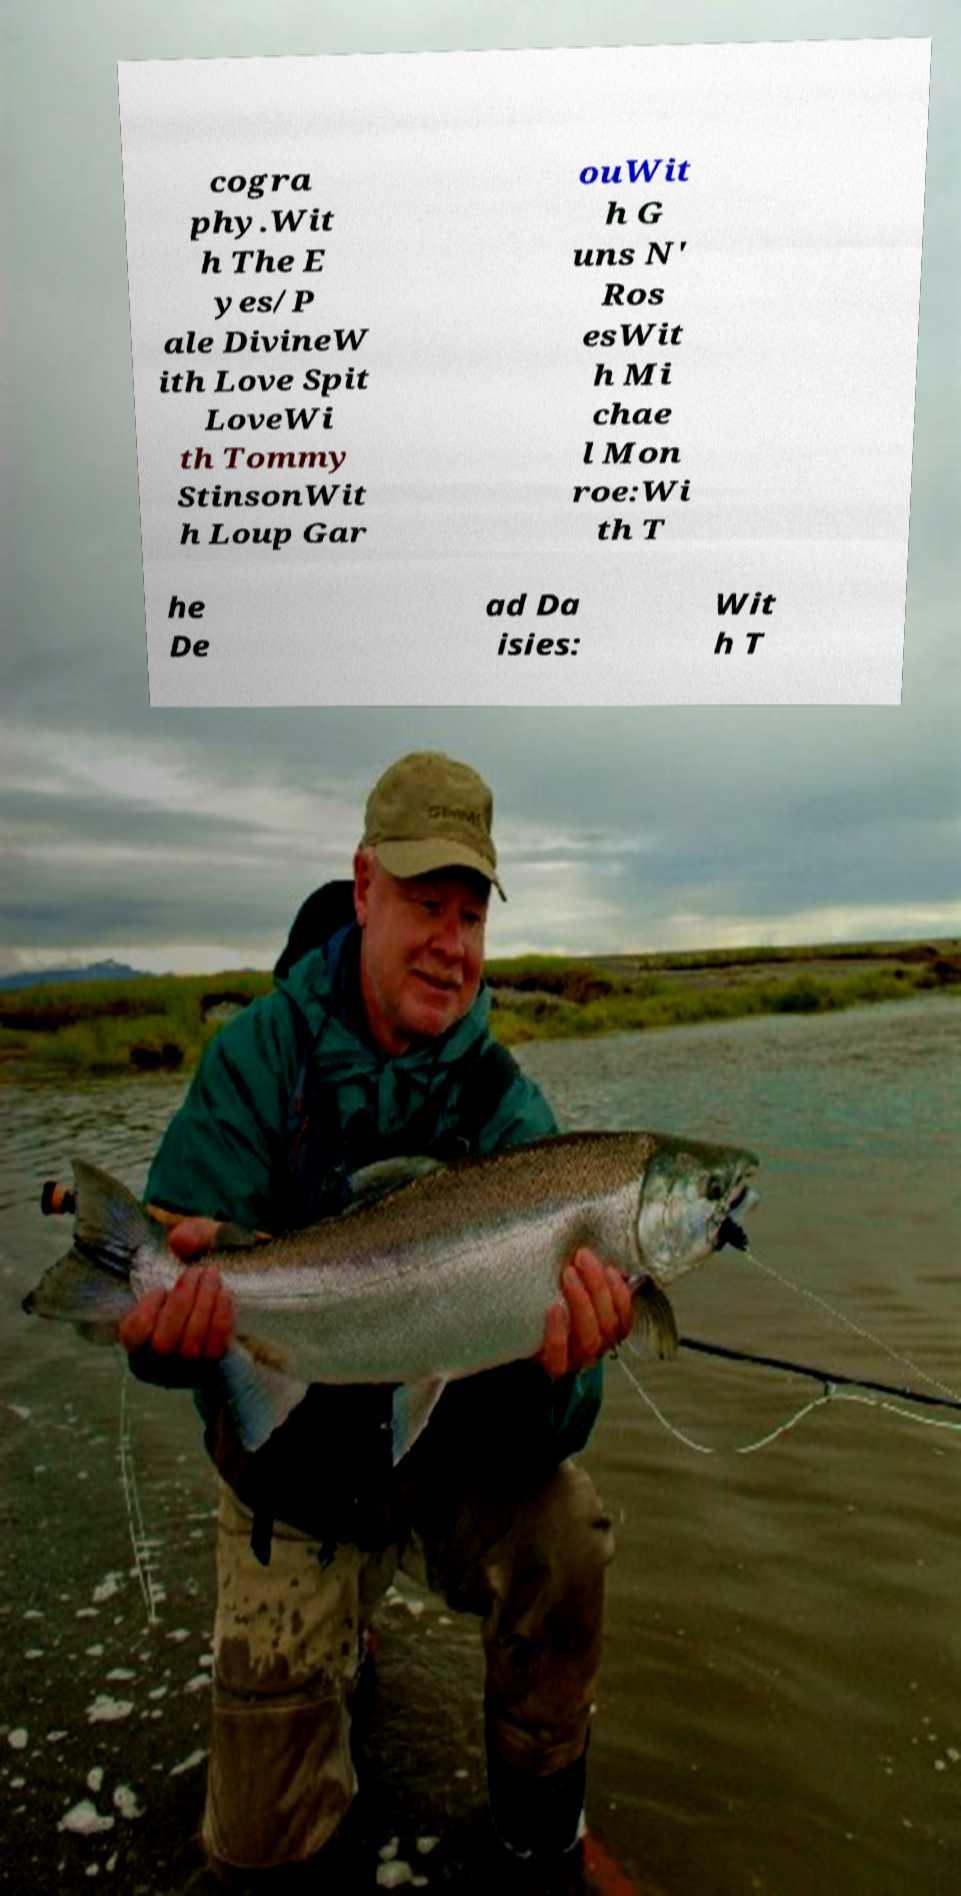Please identify and transcribe the text found in this image. cogra phy.Wit h The E yes/P ale DivineW ith Love Spit LoveWi th Tommy StinsonWit h Loup Gar ouWit h G uns N' Ros esWit h Mi chae l Mon roe:Wi th T he De ad Da isies: Wit h T 